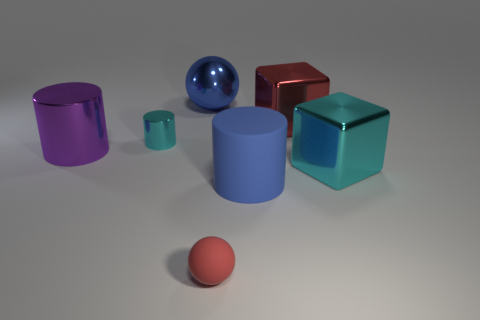Subtract all blue cylinders. How many cylinders are left? 2 Add 1 red objects. How many objects exist? 8 Subtract 1 cylinders. How many cylinders are left? 2 Subtract all cylinders. How many objects are left? 4 Subtract 0 blue cubes. How many objects are left? 7 Subtract all gray cylinders. Subtract all cyan cubes. How many cylinders are left? 3 Subtract all big cyan matte things. Subtract all tiny spheres. How many objects are left? 6 Add 2 shiny blocks. How many shiny blocks are left? 4 Add 7 large yellow rubber blocks. How many large yellow rubber blocks exist? 7 